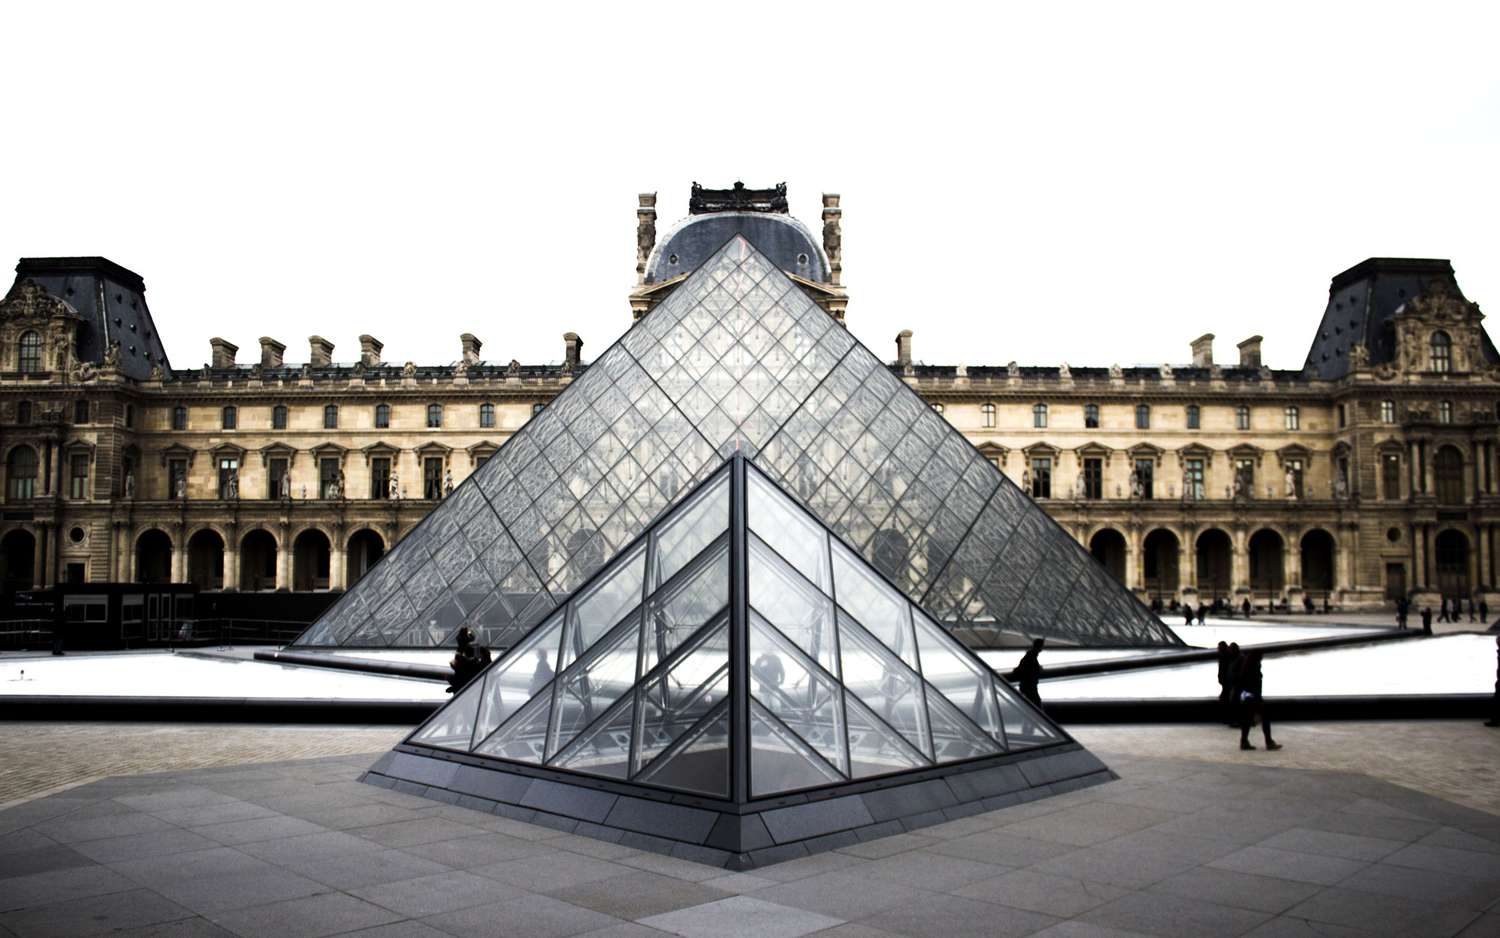Describe what kind of maintenance challenges the Louvre pyramid might face. The Louvre pyramid, while stunning, presents unique maintenance challenges due to its construction with glass and metal. Regular cleaning is essential to maintain the transparency and brilliance of the glass, which can become smudged or develop a patina over time due to weather conditions and pollution. Additionally, ensuring the stability and integrity of the metal framework is critical, requiring periodic checks and maintenance to prevent corrosion or structural weakening. Furthermore, the pool of water around the pyramid must be kept clear and clean, adding another layer to the maintenance complexity. The juxtaposition of such a modern structure within a historical setting also calls for careful preservation strategies to ensure that adjacent older artworks and structures are not compromised. How does the design of the pyramid integrate with the historical aspects of the Louvre Palace? The design of the Louvre pyramid, created by architect I. M. Pei, masterfully integrates with the historical aspects of the Louvre Palace by creating a dialogue between the ultra-modern and the classical. Its sleek, minimalistic form stands in stark, yet harmonious contrast to the ornate architecture of the palace, highlighting the historical structure's beauty through juxtaposition. The use of glass allows for transparency, symbolically creating a gateway to the past while providing unobstructed views of the Louvre's historic edifice. Furthermore, the pyramid's geometric precision and reflective surfaces catch and play with light in ways that not only showcase contemporary architectural prowess but also accentuate the timeless elegance of the museum's classical surroundings. 